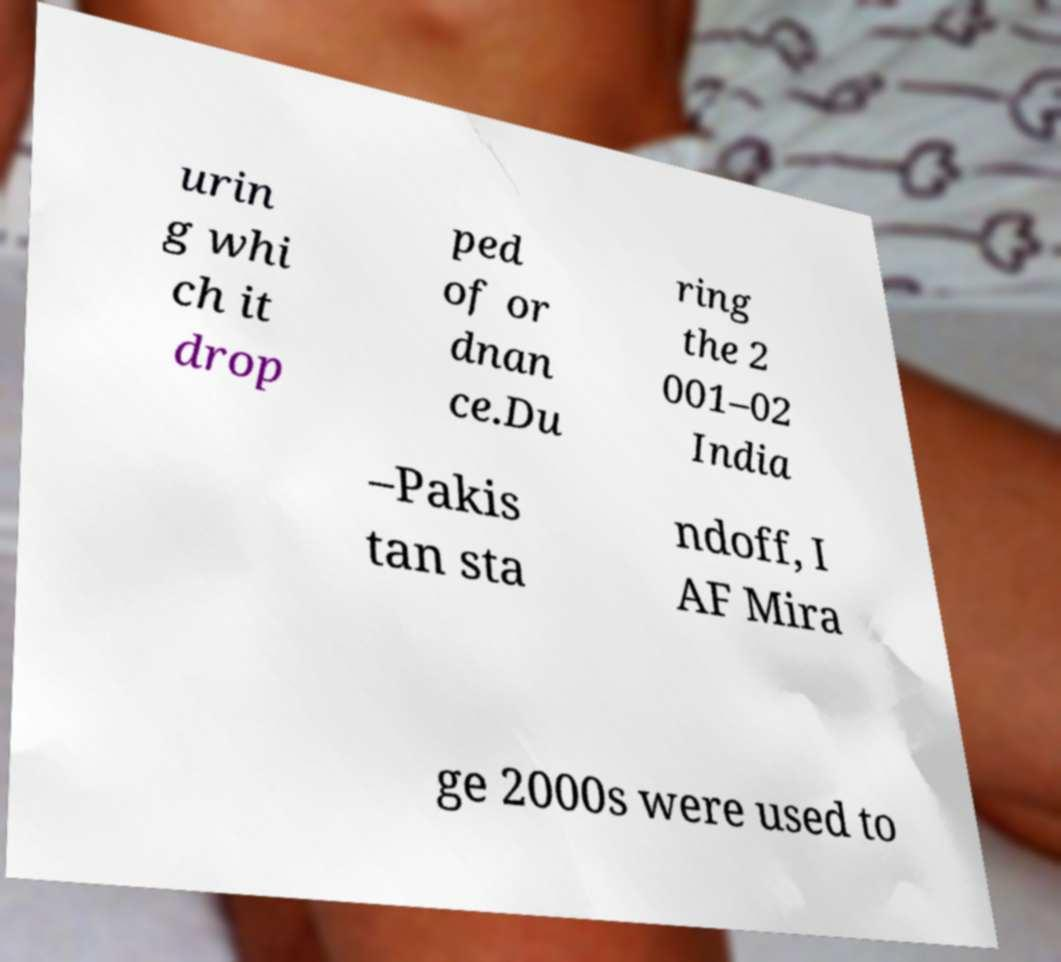Could you extract and type out the text from this image? urin g whi ch it drop ped of or dnan ce.Du ring the 2 001–02 India –Pakis tan sta ndoff, I AF Mira ge 2000s were used to 